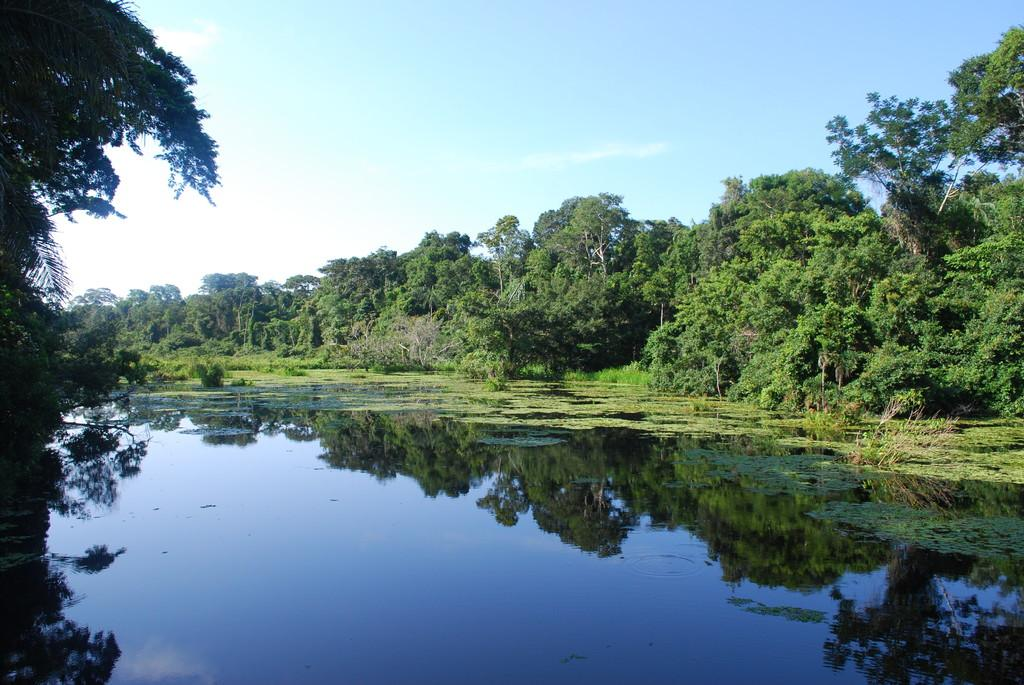What is the primary element visible in the image? There is water in the image. What types of vegetation can be seen in the image? There are plants and trees in the image. What can be seen in the background of the image? The sky is visible in the background of the image. What type of flower is being discussed in the image? There is no discussion or flower present in the image; it features water, plants, trees, and the sky. 